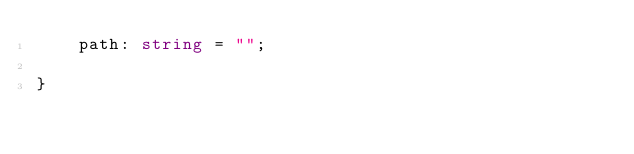Convert code to text. <code><loc_0><loc_0><loc_500><loc_500><_TypeScript_>    path: string = "";

}
</code> 